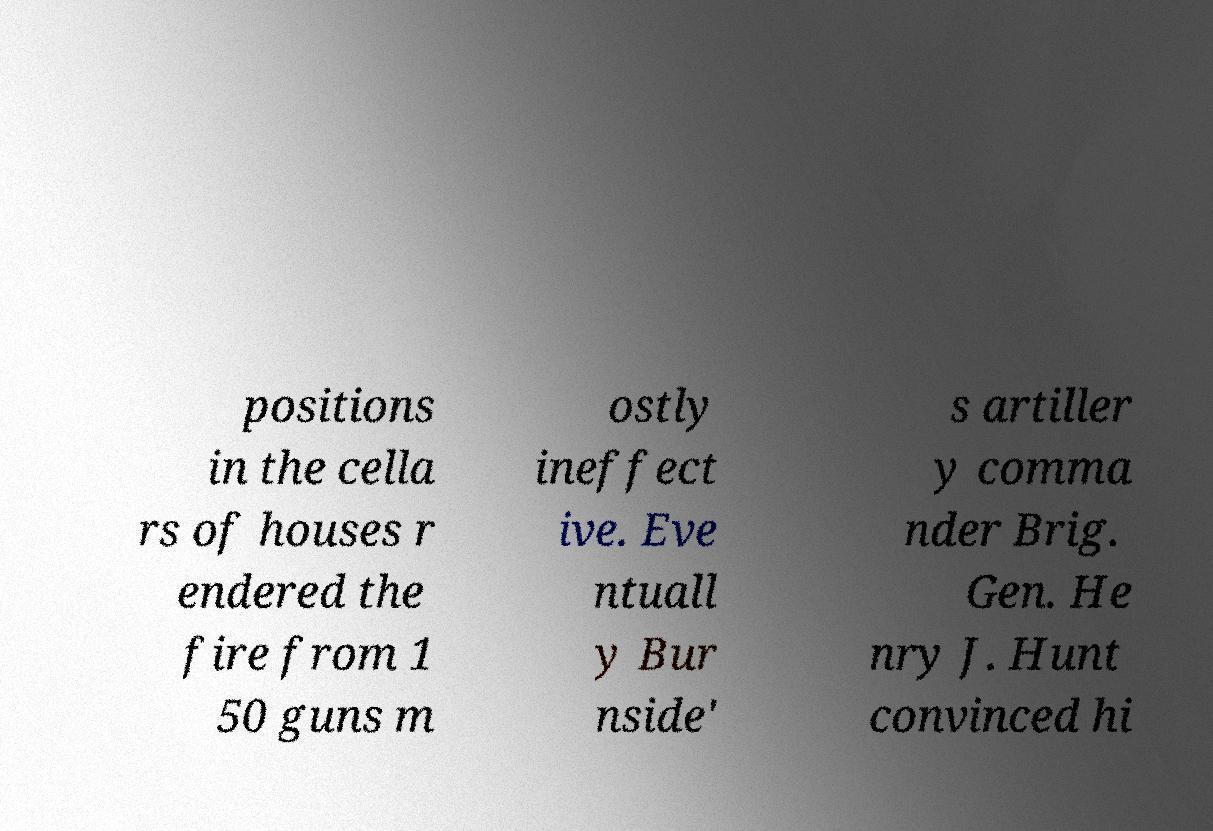For documentation purposes, I need the text within this image transcribed. Could you provide that? positions in the cella rs of houses r endered the fire from 1 50 guns m ostly ineffect ive. Eve ntuall y Bur nside' s artiller y comma nder Brig. Gen. He nry J. Hunt convinced hi 